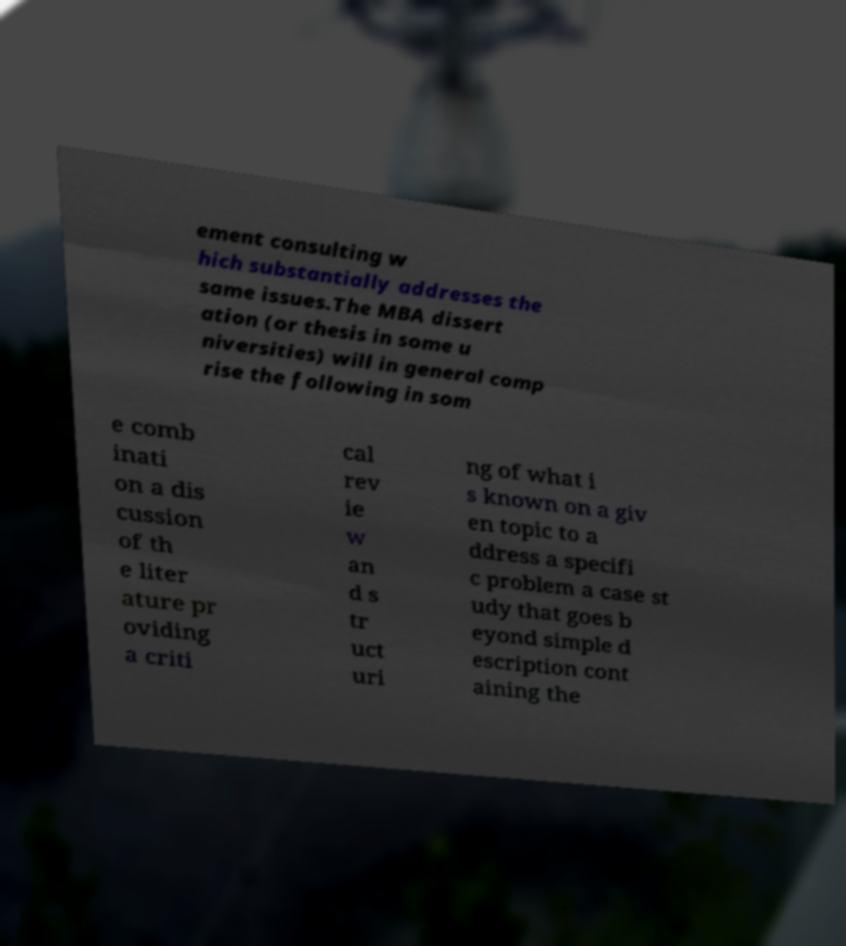Could you extract and type out the text from this image? ement consulting w hich substantially addresses the same issues.The MBA dissert ation (or thesis in some u niversities) will in general comp rise the following in som e comb inati on a dis cussion of th e liter ature pr oviding a criti cal rev ie w an d s tr uct uri ng of what i s known on a giv en topic to a ddress a specifi c problem a case st udy that goes b eyond simple d escription cont aining the 